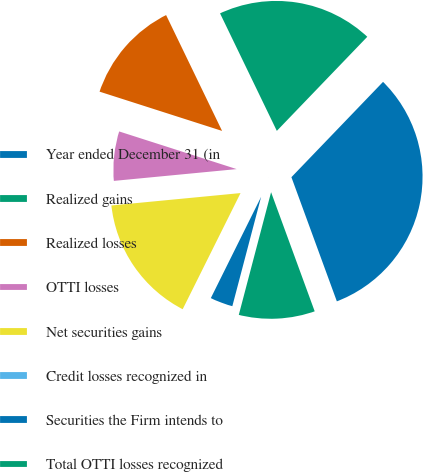Convert chart to OTSL. <chart><loc_0><loc_0><loc_500><loc_500><pie_chart><fcel>Year ended December 31 (in<fcel>Realized gains<fcel>Realized losses<fcel>OTTI losses<fcel>Net securities gains<fcel>Credit losses recognized in<fcel>Securities the Firm intends to<fcel>Total OTTI losses recognized<nl><fcel>32.23%<fcel>19.35%<fcel>12.9%<fcel>6.46%<fcel>16.12%<fcel>0.02%<fcel>3.24%<fcel>9.68%<nl></chart> 